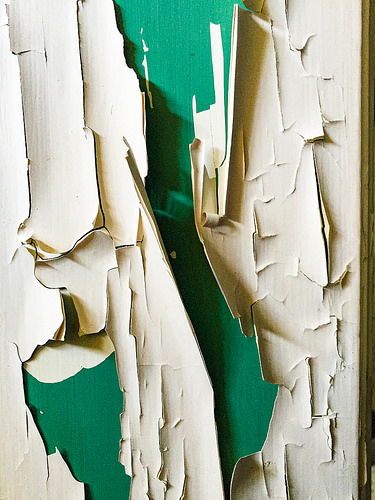<image>
Is there a green paint under the white paint? Yes. The green paint is positioned underneath the white paint, with the white paint above it in the vertical space. 